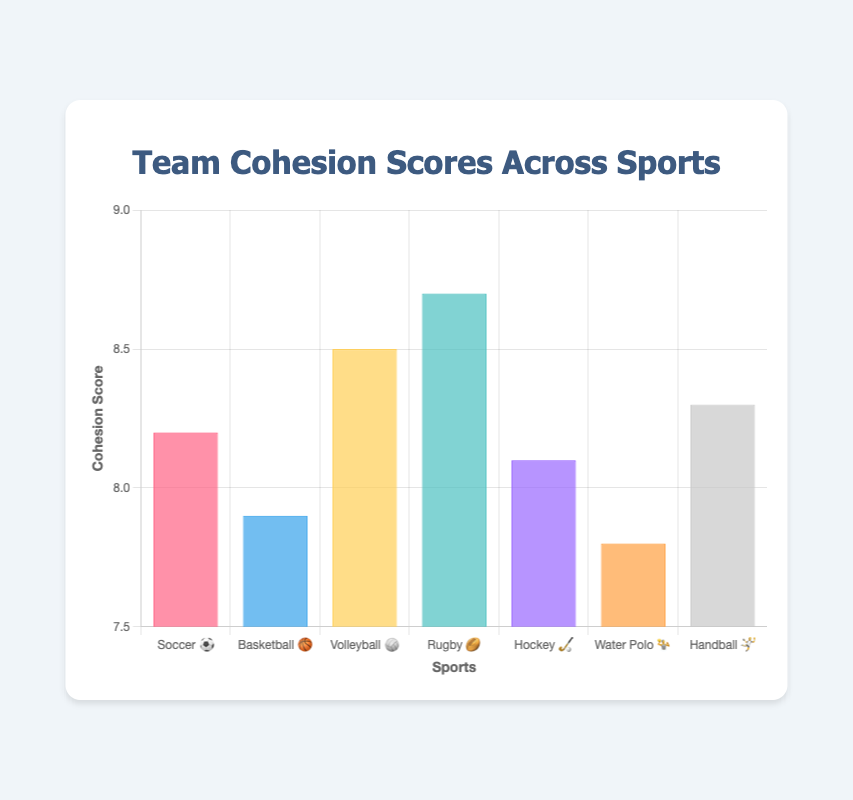What is the title of the figure? The title is always displayed prominently at the top of the chart container. In this case, it reads "Team Cohesion Scores Across Sports".
Answer: Team Cohesion Scores Across Sports How many sports are represented in the chart? The number of sports can be counted by referring to the labels on the x-axis. There are 7 sports represented.
Answer: 7 Which sport has the highest cohesion score? Look at the height of the bars in the chart. The tallest bar represents Rugby with a score of 8.7.
Answer: Rugby Which sport has the lowest cohesion score? Identify the shortest bar in the chart. The shortest bar represents Water Polo with a score of 7.8.
Answer: Water Polo What is the average cohesion score across all the sports? Sum up all the cohesion scores and divide by the number of sports. (8.2 + 7.9 + 8.5 + 8.7 + 8.1 + 7.8 + 8.3) / 7 = 57.5 / 7.
Answer: 8.21 What is the difference in cohesion score between Volleyball and Basketball? Subtract the cohesion score of Basketball from that of Volleyball. 8.5 - 7.9 = 0.6.
Answer: 0.6 Which sports have a cohesion score greater than 8.0? Refer to the heights of the bars and the tick marks on the y-axis to identify bars taller than the 8.0 mark. Soccer, Volleyball, Rugby, Hockey, and Handball have scores greater than 8.0.
Answer: Soccer, Volleyball, Rugby, Hockey, Handball How many sports have a cohesion score between 7.5 and 8.5? Count the number of bars that fall within this range by comparing their heights with the y-axis labels. There are 5 sports: Soccer, Basketball, Volleyball, Hockey, and Handball.
Answer: 5 Which sport has a cohesion score closest to the average score? Calculate the difference between each sport's cohesion score and the average cohesion score (8.21), and identify the smallest difference. Handball's score of 8.3 is the closest.
Answer: Handball What color represents the cohesion score for Water Polo? Each bar in the figure is colored differently, and the colors are listed in the provided data. Water Polo is represented by an orange bar.
Answer: Orange 